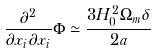<formula> <loc_0><loc_0><loc_500><loc_500>\frac { \partial ^ { 2 } } { \partial x _ { i } \partial x _ { i } } \Phi \simeq \frac { 3 H _ { 0 } ^ { 2 } \Omega _ { m } \delta } { 2 a }</formula> 